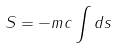<formula> <loc_0><loc_0><loc_500><loc_500>S = - m c \int d s</formula> 